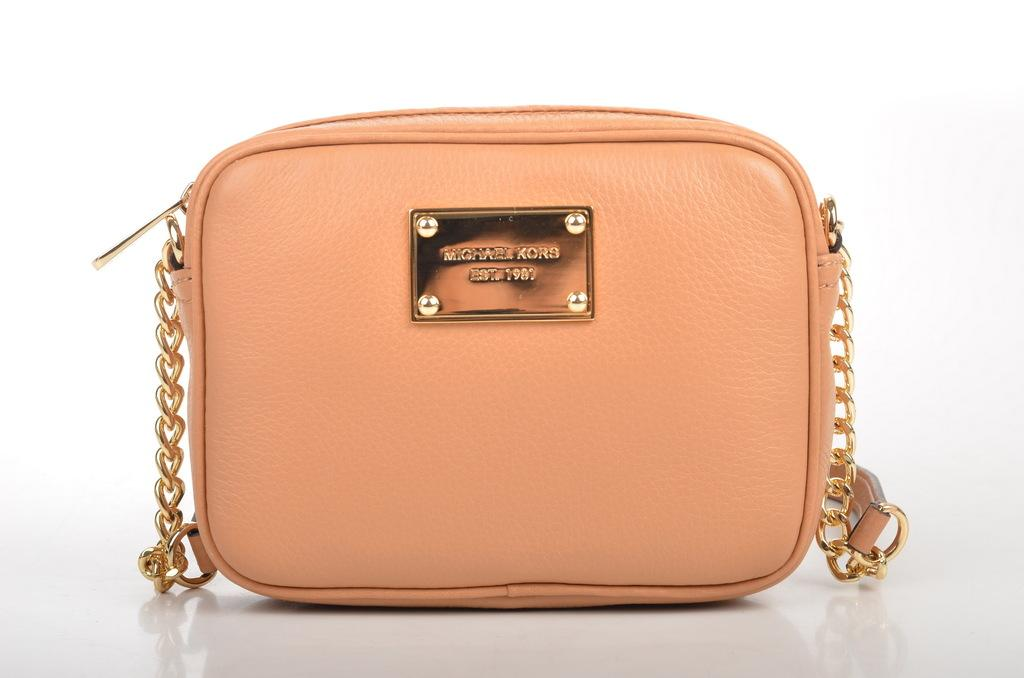What type of bag is in the image? There is a peach-colored bag in the image. What feature does the bag have? The bag has a handle. What is the color of the handle? The handle is in golden color. What type of toy can be seen in the advertisement in the image? There is no toy or advertisement present in the image; it only features a peach-colored bag with a golden handle. 